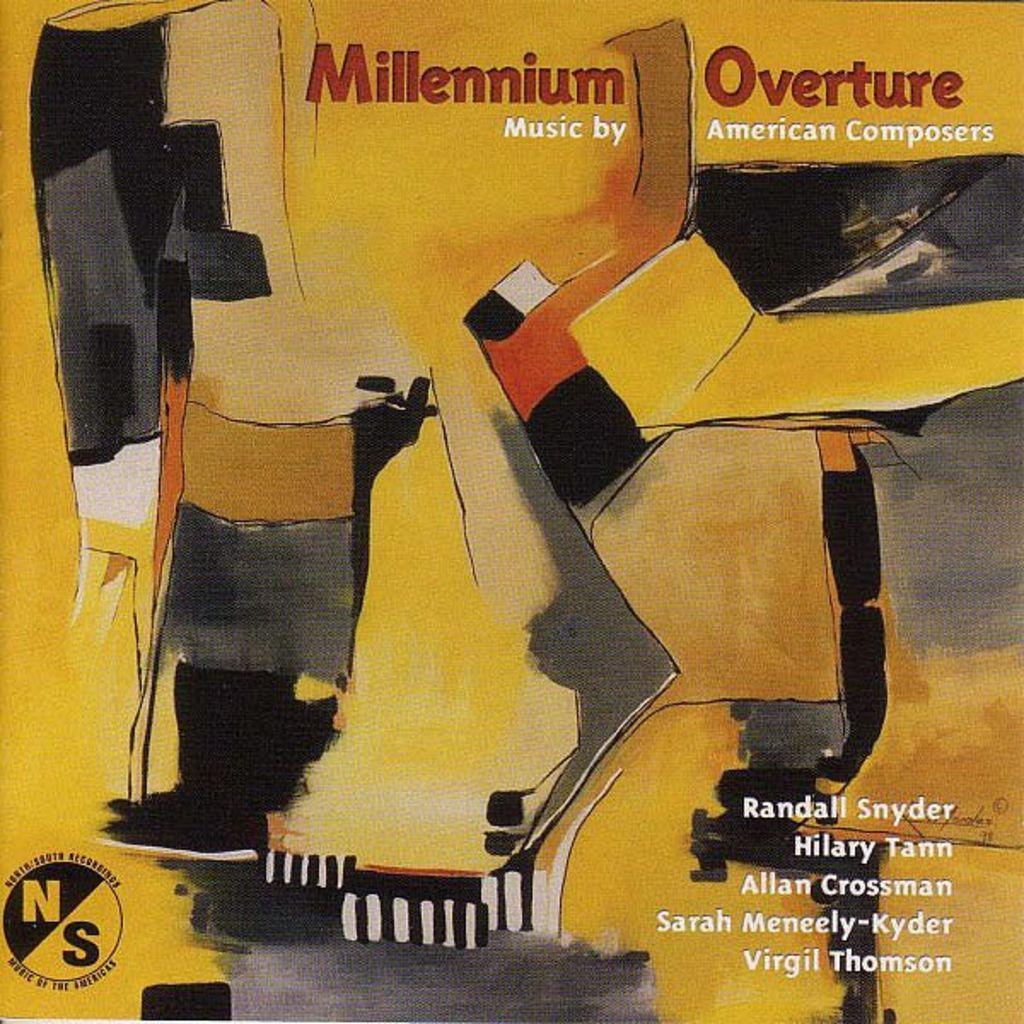<image>
Relay a brief, clear account of the picture shown. An album cover for Millennium Overture by American Composers. 